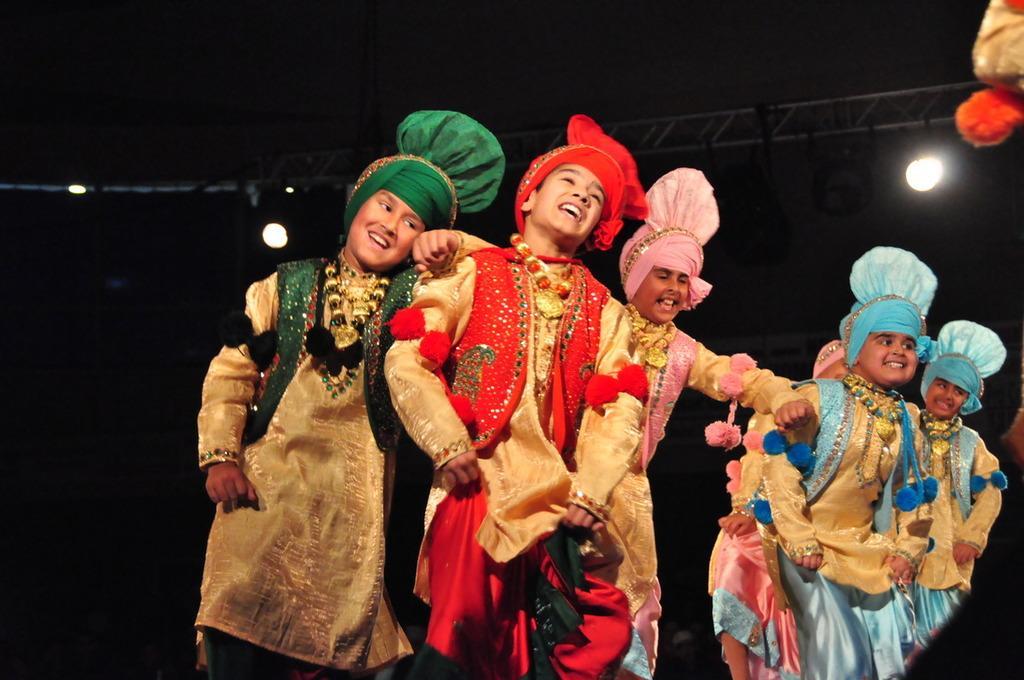Can you describe this image briefly? In this image, we can see kids are wearing costumes. Few kids are smiling. Background there is a dark view. Here we can see rods and lights. 